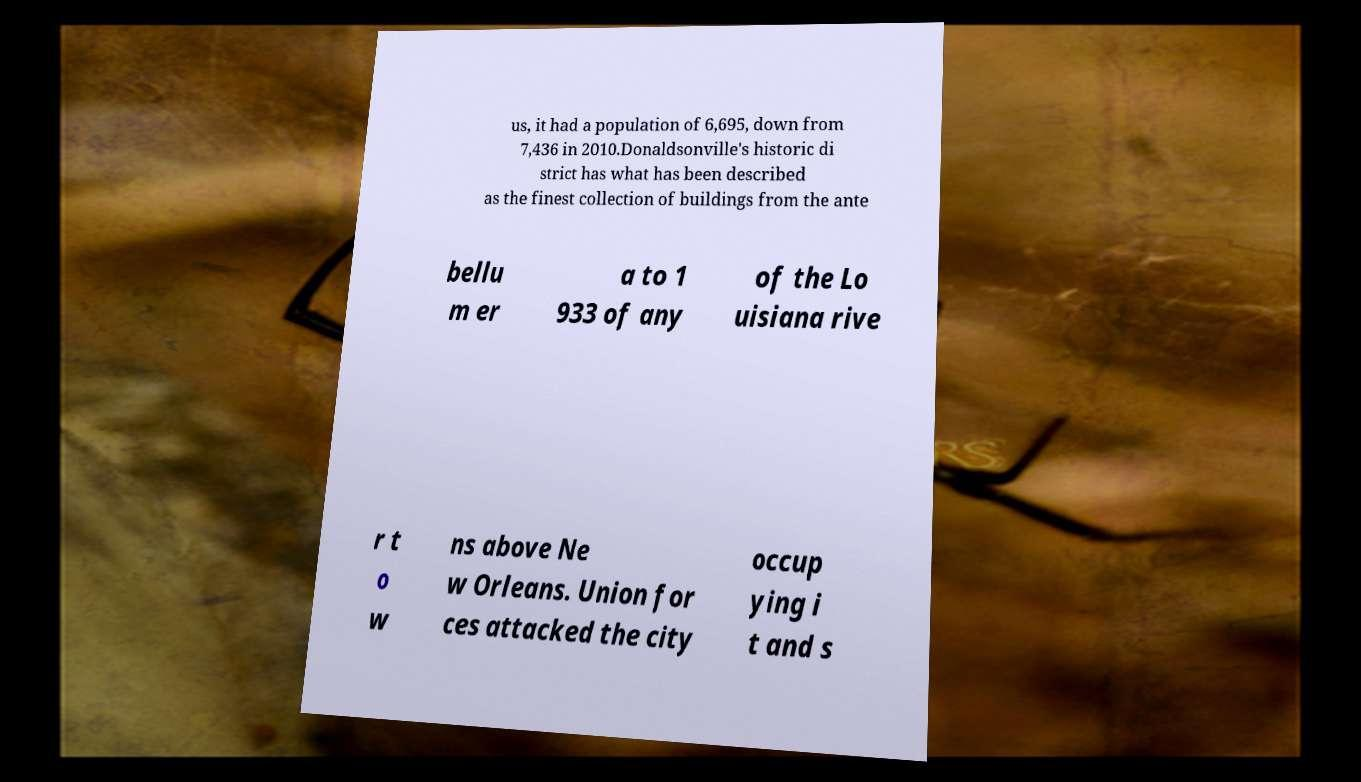Please identify and transcribe the text found in this image. us, it had a population of 6,695, down from 7,436 in 2010.Donaldsonville's historic di strict has what has been described as the finest collection of buildings from the ante bellu m er a to 1 933 of any of the Lo uisiana rive r t o w ns above Ne w Orleans. Union for ces attacked the city occup ying i t and s 